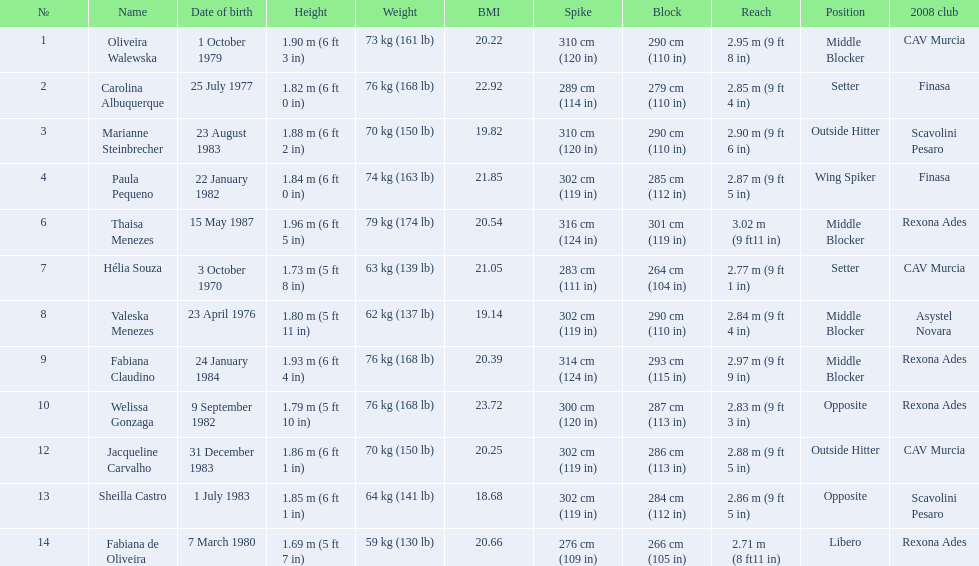Who are the players for brazil at the 2008 summer olympics? Oliveira Walewska, Carolina Albuquerque, Marianne Steinbrecher, Paula Pequeno, Thaisa Menezes, Hélia Souza, Valeska Menezes, Fabiana Claudino, Welissa Gonzaga, Jacqueline Carvalho, Sheilla Castro, Fabiana de Oliveira. What are their heights? 1.90 m (6 ft 3 in), 1.82 m (6 ft 0 in), 1.88 m (6 ft 2 in), 1.84 m (6 ft 0 in), 1.96 m (6 ft 5 in), 1.73 m (5 ft 8 in), 1.80 m (5 ft 11 in), 1.93 m (6 ft 4 in), 1.79 m (5 ft 10 in), 1.86 m (6 ft 1 in), 1.85 m (6 ft 1 in), 1.69 m (5 ft 7 in). What is the shortest height? 1.69 m (5 ft 7 in). Which player is that? Fabiana de Oliveira. 